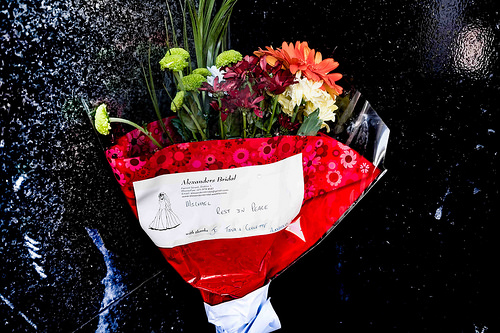<image>
Is the bride next to the flowers? No. The bride is not positioned next to the flowers. They are located in different areas of the scene. 